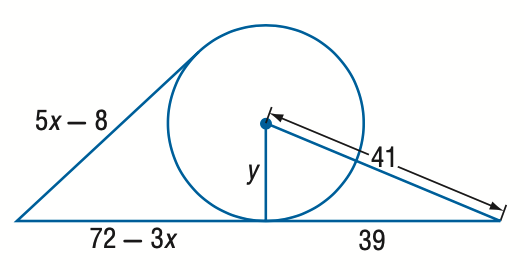Answer the mathemtical geometry problem and directly provide the correct option letter.
Question: Find y. Assume that segments that appear to be tangent are tangent. Round to the nearest tenth if necessary.
Choices: A: 10.6 B: 11.6 C: 12.6 D: 13.6 C 